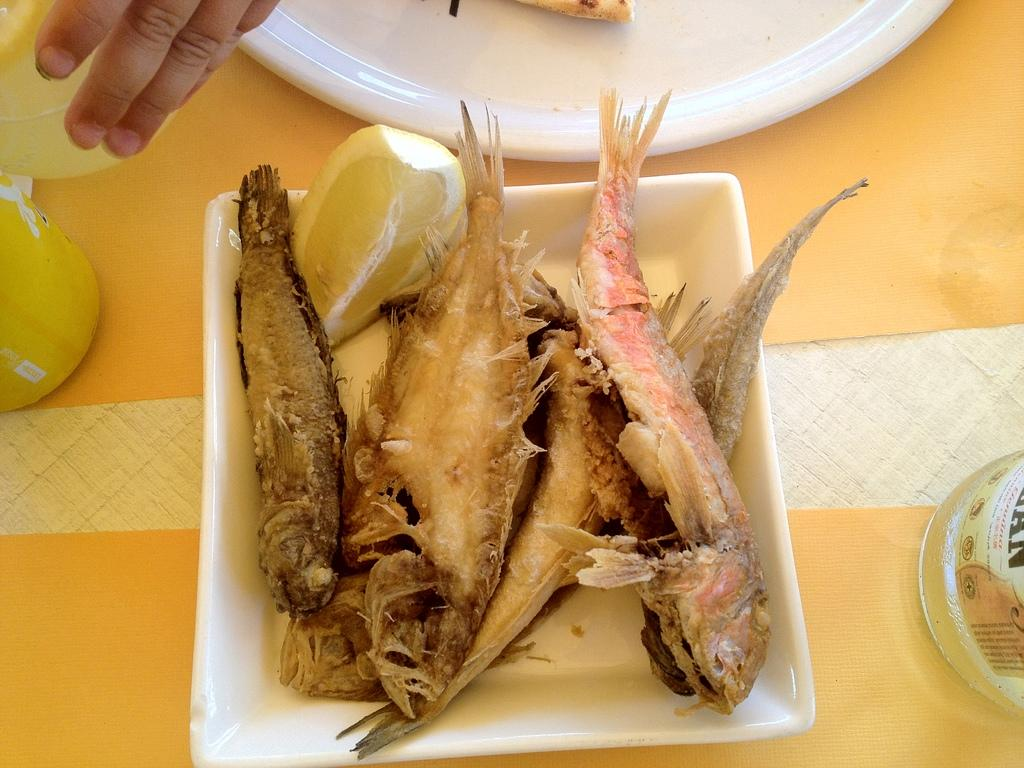What type of animals can be seen in the image? There are fishes in the image. What is the other object visible in the image? There is a lemon piece in the image. Where are the fishes and lemon piece located? The fishes and lemon piece are in a tray. What else can be seen on the table in the image? There is a plate and bottles on the table. What is a human hand doing in the image? A human hand is holding a bottle in the image. What sound does the goose make while holding the parcel in the image? There is no goose or parcel present in the image. Why is the person crying while holding the lemon piece in the image? There is no person crying in the image, and the lemon piece is not being held by a person. 